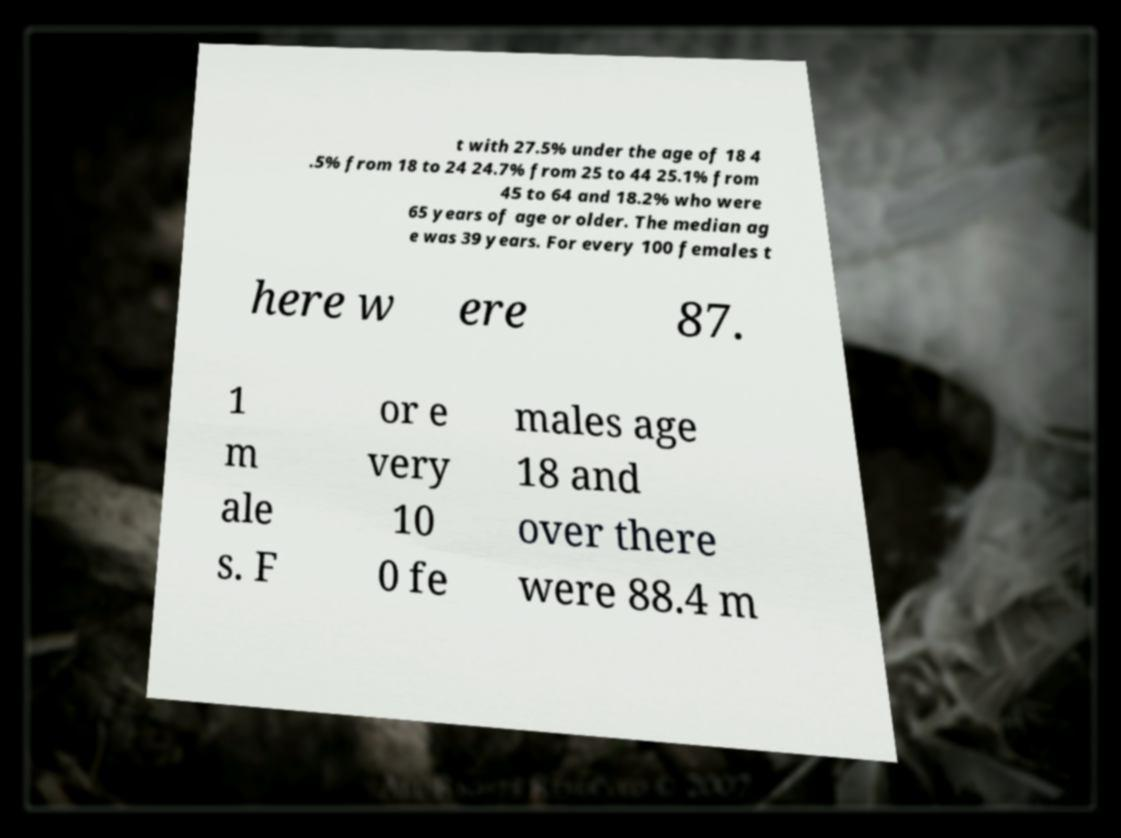Please identify and transcribe the text found in this image. t with 27.5% under the age of 18 4 .5% from 18 to 24 24.7% from 25 to 44 25.1% from 45 to 64 and 18.2% who were 65 years of age or older. The median ag e was 39 years. For every 100 females t here w ere 87. 1 m ale s. F or e very 10 0 fe males age 18 and over there were 88.4 m 